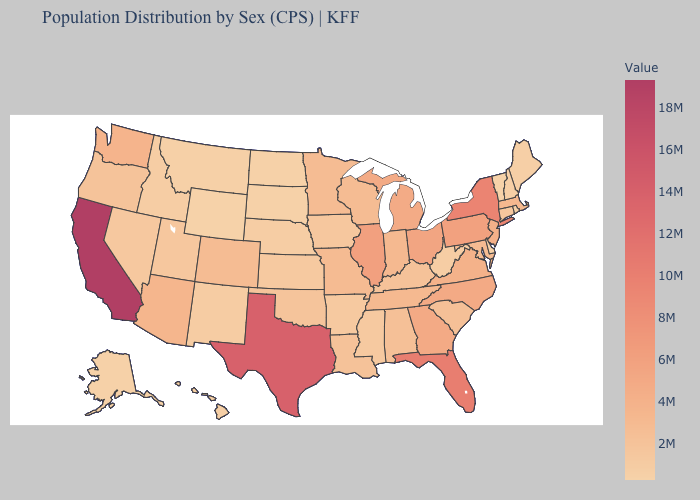Does the map have missing data?
Answer briefly. No. Does Georgia have a higher value than South Dakota?
Be succinct. Yes. Among the states that border Connecticut , which have the highest value?
Be succinct. New York. Among the states that border Nevada , which have the lowest value?
Concise answer only. Idaho. Among the states that border Oregon , does Idaho have the highest value?
Quick response, please. No. Among the states that border Texas , which have the highest value?
Write a very short answer. Louisiana. 